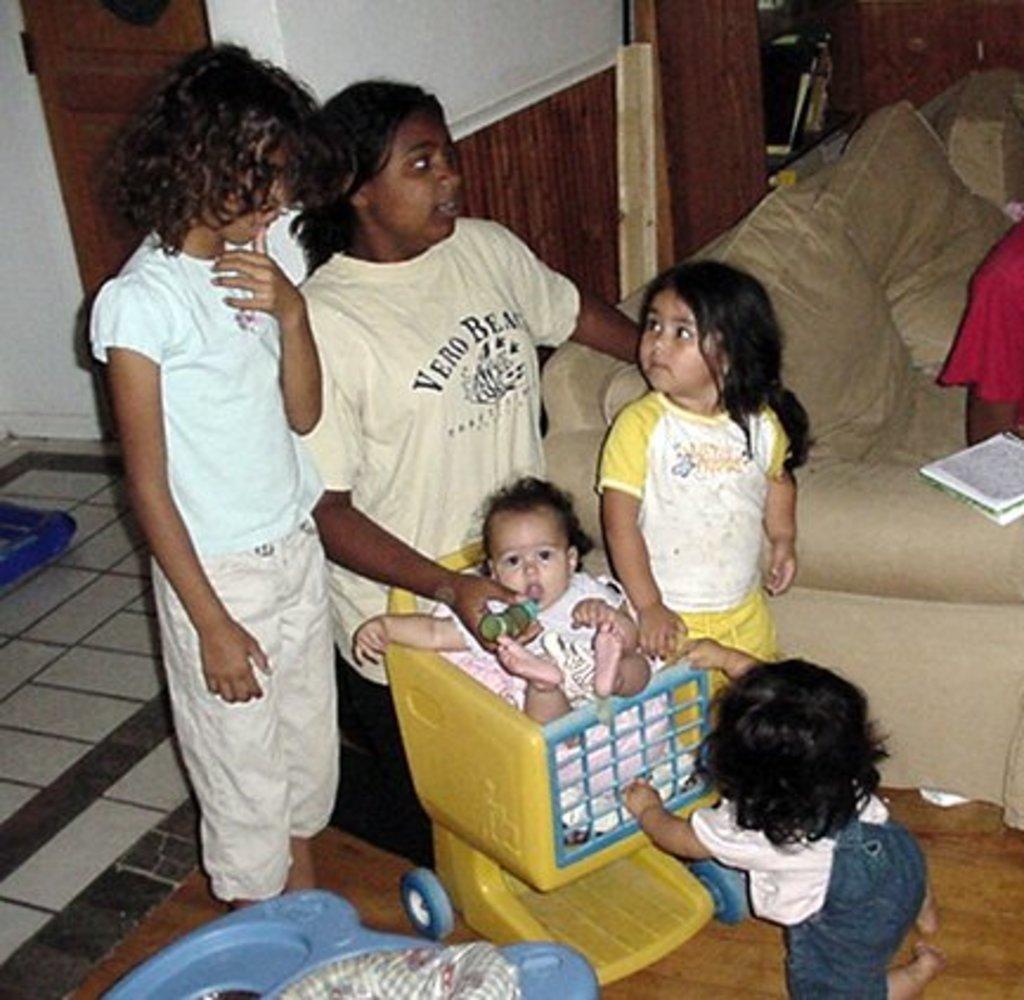Describe this image in one or two sentences. In the center of the image we can see persons standing at the baby. In the background we can see bed, pillows, door and wall. 